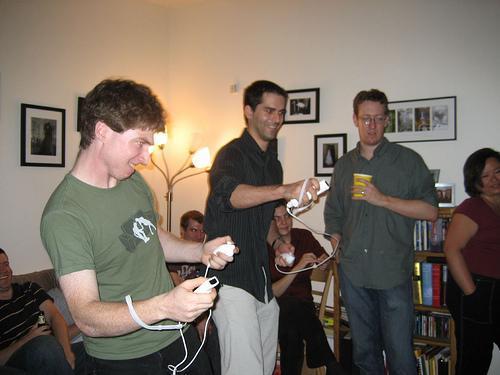How many men are wearing black shirts?
Give a very brief answer. 1. How many people are in the photo?
Give a very brief answer. 7. How many yellow shirts are in this picture?
Give a very brief answer. 0. How many in this photo are standing?
Give a very brief answer. 4. How many people can you see?
Give a very brief answer. 6. How many yellow umbrellas are in this photo?
Give a very brief answer. 0. 